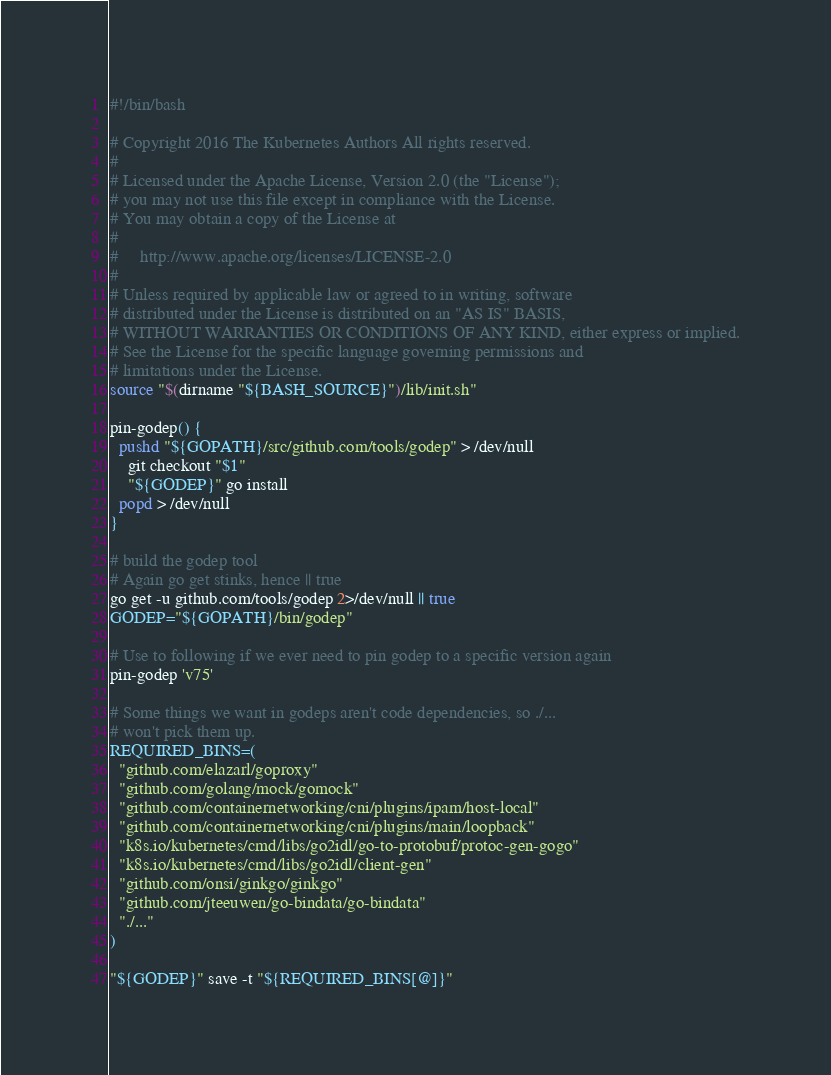Convert code to text. <code><loc_0><loc_0><loc_500><loc_500><_Bash_>#!/bin/bash

# Copyright 2016 The Kubernetes Authors All rights reserved.
#
# Licensed under the Apache License, Version 2.0 (the "License");
# you may not use this file except in compliance with the License.
# You may obtain a copy of the License at
#
#     http://www.apache.org/licenses/LICENSE-2.0
#
# Unless required by applicable law or agreed to in writing, software
# distributed under the License is distributed on an "AS IS" BASIS,
# WITHOUT WARRANTIES OR CONDITIONS OF ANY KIND, either express or implied.
# See the License for the specific language governing permissions and
# limitations under the License.
source "$(dirname "${BASH_SOURCE}")/lib/init.sh"

pin-godep() {
  pushd "${GOPATH}/src/github.com/tools/godep" > /dev/null
    git checkout "$1"
    "${GODEP}" go install
  popd > /dev/null
}

# build the godep tool
# Again go get stinks, hence || true
go get -u github.com/tools/godep 2>/dev/null || true
GODEP="${GOPATH}/bin/godep"

# Use to following if we ever need to pin godep to a specific version again
pin-godep 'v75'

# Some things we want in godeps aren't code dependencies, so ./...
# won't pick them up.
REQUIRED_BINS=(
  "github.com/elazarl/goproxy"
  "github.com/golang/mock/gomock"
  "github.com/containernetworking/cni/plugins/ipam/host-local"
  "github.com/containernetworking/cni/plugins/main/loopback"
  "k8s.io/kubernetes/cmd/libs/go2idl/go-to-protobuf/protoc-gen-gogo"
  "k8s.io/kubernetes/cmd/libs/go2idl/client-gen"
  "github.com/onsi/ginkgo/ginkgo"
  "github.com/jteeuwen/go-bindata/go-bindata"
  "./..."
)

"${GODEP}" save -t "${REQUIRED_BINS[@]}"
</code> 